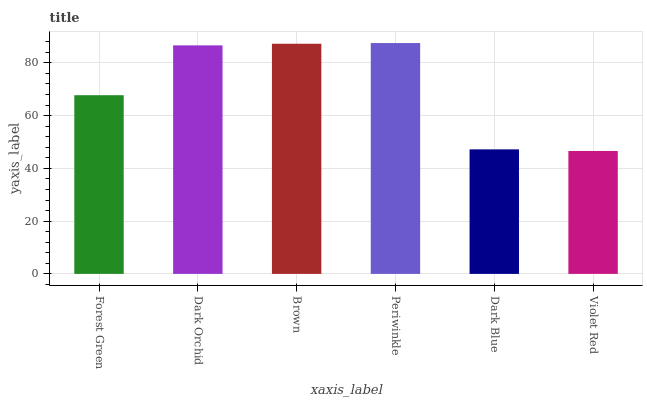Is Violet Red the minimum?
Answer yes or no. Yes. Is Periwinkle the maximum?
Answer yes or no. Yes. Is Dark Orchid the minimum?
Answer yes or no. No. Is Dark Orchid the maximum?
Answer yes or no. No. Is Dark Orchid greater than Forest Green?
Answer yes or no. Yes. Is Forest Green less than Dark Orchid?
Answer yes or no. Yes. Is Forest Green greater than Dark Orchid?
Answer yes or no. No. Is Dark Orchid less than Forest Green?
Answer yes or no. No. Is Dark Orchid the high median?
Answer yes or no. Yes. Is Forest Green the low median?
Answer yes or no. Yes. Is Brown the high median?
Answer yes or no. No. Is Brown the low median?
Answer yes or no. No. 